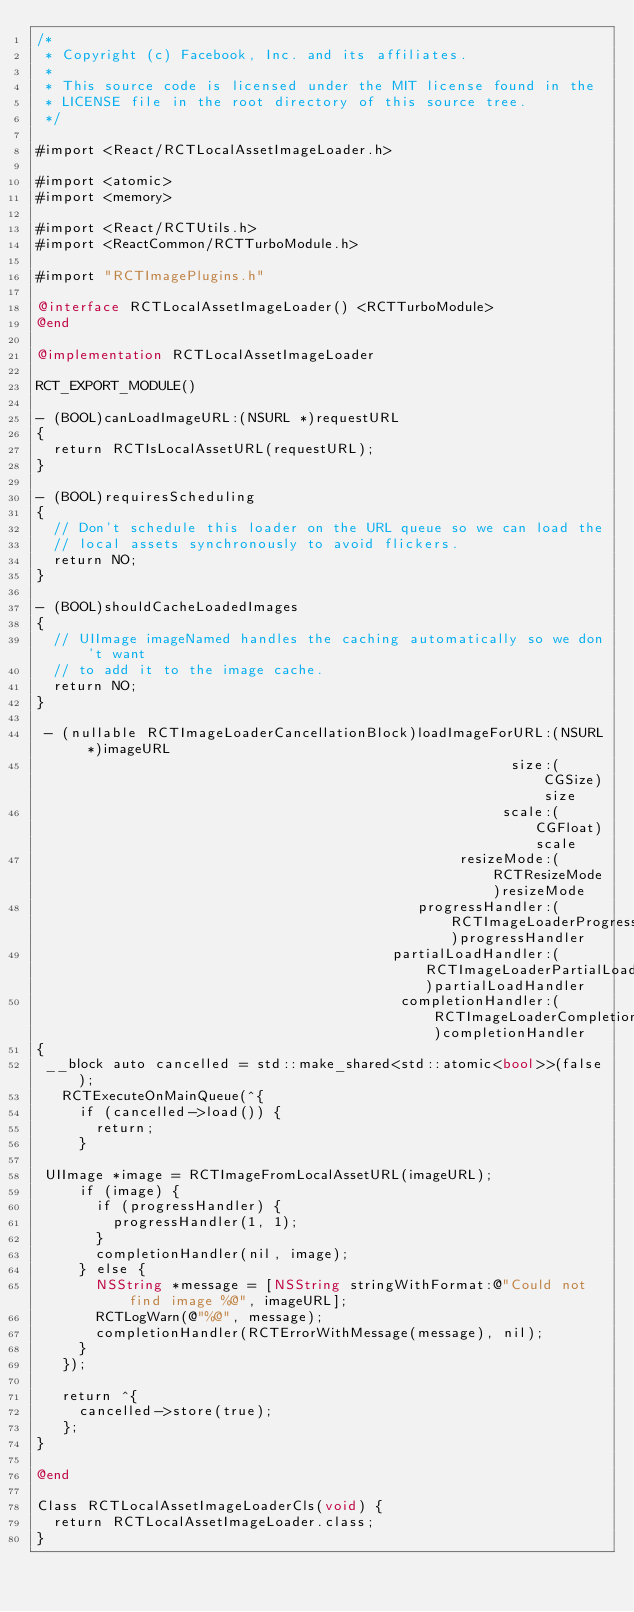Convert code to text. <code><loc_0><loc_0><loc_500><loc_500><_ObjectiveC_>/*
 * Copyright (c) Facebook, Inc. and its affiliates.
 *
 * This source code is licensed under the MIT license found in the
 * LICENSE file in the root directory of this source tree.
 */

#import <React/RCTLocalAssetImageLoader.h>

#import <atomic>
#import <memory>

#import <React/RCTUtils.h>
#import <ReactCommon/RCTTurboModule.h>

#import "RCTImagePlugins.h"

@interface RCTLocalAssetImageLoader() <RCTTurboModule>
@end

@implementation RCTLocalAssetImageLoader

RCT_EXPORT_MODULE()

- (BOOL)canLoadImageURL:(NSURL *)requestURL
{
  return RCTIsLocalAssetURL(requestURL);
}

- (BOOL)requiresScheduling
{
  // Don't schedule this loader on the URL queue so we can load the
  // local assets synchronously to avoid flickers.
  return NO;
}

- (BOOL)shouldCacheLoadedImages
{
  // UIImage imageNamed handles the caching automatically so we don't want
  // to add it to the image cache.
  return NO;
}

 - (nullable RCTImageLoaderCancellationBlock)loadImageForURL:(NSURL *)imageURL
                                                        size:(CGSize)size
                                                       scale:(CGFloat)scale
                                                  resizeMode:(RCTResizeMode)resizeMode
                                             progressHandler:(RCTImageLoaderProgressBlock)progressHandler
                                          partialLoadHandler:(RCTImageLoaderPartialLoadBlock)partialLoadHandler
                                           completionHandler:(RCTImageLoaderCompletionBlock)completionHandler
{
 __block auto cancelled = std::make_shared<std::atomic<bool>>(false);
   RCTExecuteOnMainQueue(^{
     if (cancelled->load()) {
       return;
     }

 UIImage *image = RCTImageFromLocalAssetURL(imageURL);
     if (image) {
       if (progressHandler) {
         progressHandler(1, 1);
       }
       completionHandler(nil, image);
     } else {
       NSString *message = [NSString stringWithFormat:@"Could not find image %@", imageURL];
       RCTLogWarn(@"%@", message);
       completionHandler(RCTErrorWithMessage(message), nil);
     }
   });

   return ^{
     cancelled->store(true);
   };
}

@end

Class RCTLocalAssetImageLoaderCls(void) {
  return RCTLocalAssetImageLoader.class;
}
</code> 